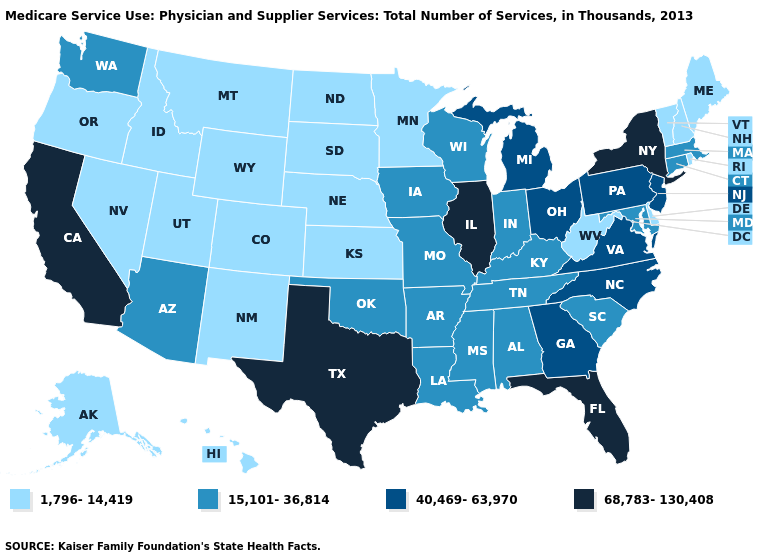Which states have the lowest value in the Northeast?
Give a very brief answer. Maine, New Hampshire, Rhode Island, Vermont. Which states have the lowest value in the South?
Concise answer only. Delaware, West Virginia. Does California have the highest value in the West?
Write a very short answer. Yes. Which states have the lowest value in the USA?
Keep it brief. Alaska, Colorado, Delaware, Hawaii, Idaho, Kansas, Maine, Minnesota, Montana, Nebraska, Nevada, New Hampshire, New Mexico, North Dakota, Oregon, Rhode Island, South Dakota, Utah, Vermont, West Virginia, Wyoming. What is the lowest value in states that border North Carolina?
Be succinct. 15,101-36,814. What is the value of California?
Write a very short answer. 68,783-130,408. Name the states that have a value in the range 68,783-130,408?
Answer briefly. California, Florida, Illinois, New York, Texas. What is the value of Idaho?
Quick response, please. 1,796-14,419. What is the lowest value in states that border Massachusetts?
Give a very brief answer. 1,796-14,419. What is the value of Maryland?
Concise answer only. 15,101-36,814. Does the map have missing data?
Be succinct. No. Among the states that border Utah , which have the highest value?
Answer briefly. Arizona. Name the states that have a value in the range 40,469-63,970?
Concise answer only. Georgia, Michigan, New Jersey, North Carolina, Ohio, Pennsylvania, Virginia. Among the states that border Colorado , does New Mexico have the lowest value?
Write a very short answer. Yes. Does Texas have the same value as New York?
Answer briefly. Yes. 